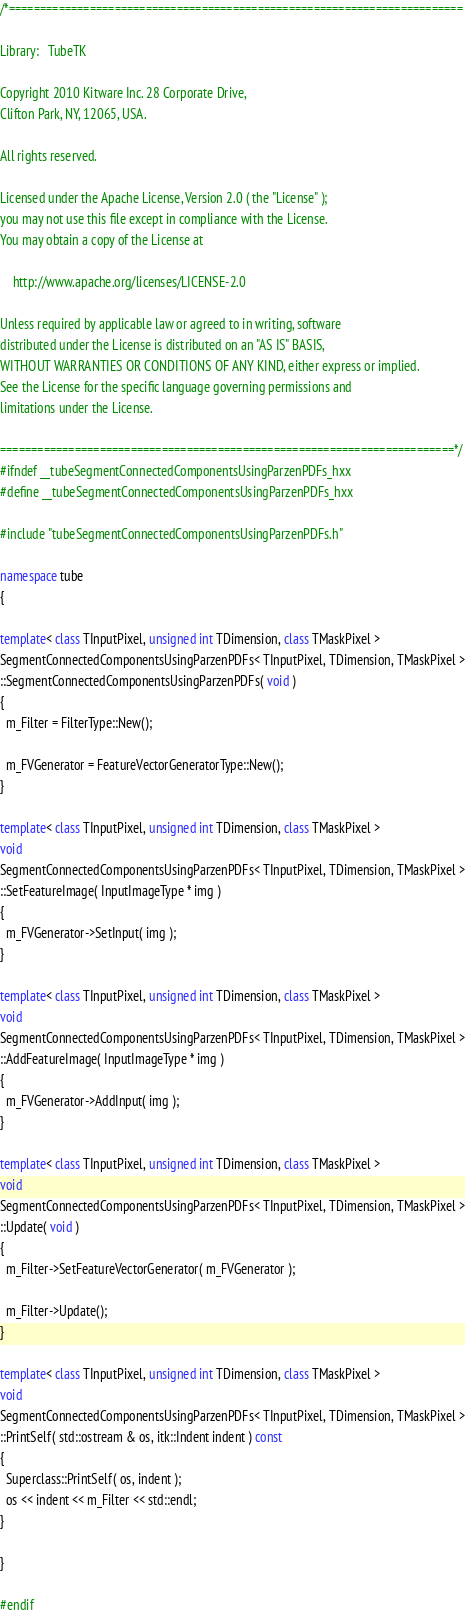<code> <loc_0><loc_0><loc_500><loc_500><_C++_>/*=========================================================================

Library:   TubeTK

Copyright 2010 Kitware Inc. 28 Corporate Drive,
Clifton Park, NY, 12065, USA.

All rights reserved.

Licensed under the Apache License, Version 2.0 ( the "License" );
you may not use this file except in compliance with the License.
You may obtain a copy of the License at

    http://www.apache.org/licenses/LICENSE-2.0

Unless required by applicable law or agreed to in writing, software
distributed under the License is distributed on an "AS IS" BASIS,
WITHOUT WARRANTIES OR CONDITIONS OF ANY KIND, either express or implied.
See the License for the specific language governing permissions and
limitations under the License.

=========================================================================*/
#ifndef __tubeSegmentConnectedComponentsUsingParzenPDFs_hxx
#define __tubeSegmentConnectedComponentsUsingParzenPDFs_hxx

#include "tubeSegmentConnectedComponentsUsingParzenPDFs.h"

namespace tube
{

template< class TInputPixel, unsigned int TDimension, class TMaskPixel >
SegmentConnectedComponentsUsingParzenPDFs< TInputPixel, TDimension, TMaskPixel >
::SegmentConnectedComponentsUsingParzenPDFs( void )
{
  m_Filter = FilterType::New();

  m_FVGenerator = FeatureVectorGeneratorType::New();
}

template< class TInputPixel, unsigned int TDimension, class TMaskPixel >
void
SegmentConnectedComponentsUsingParzenPDFs< TInputPixel, TDimension, TMaskPixel >
::SetFeatureImage( InputImageType * img )
{
  m_FVGenerator->SetInput( img );
}

template< class TInputPixel, unsigned int TDimension, class TMaskPixel >
void
SegmentConnectedComponentsUsingParzenPDFs< TInputPixel, TDimension, TMaskPixel >
::AddFeatureImage( InputImageType * img )
{
  m_FVGenerator->AddInput( img );
}

template< class TInputPixel, unsigned int TDimension, class TMaskPixel >
void
SegmentConnectedComponentsUsingParzenPDFs< TInputPixel, TDimension, TMaskPixel >
::Update( void )
{
  m_Filter->SetFeatureVectorGenerator( m_FVGenerator );

  m_Filter->Update();
}

template< class TInputPixel, unsigned int TDimension, class TMaskPixel >
void
SegmentConnectedComponentsUsingParzenPDFs< TInputPixel, TDimension, TMaskPixel >
::PrintSelf( std::ostream & os, itk::Indent indent ) const
{
  Superclass::PrintSelf( os, indent );
  os << indent << m_Filter << std::endl;
}

}

#endif
</code> 